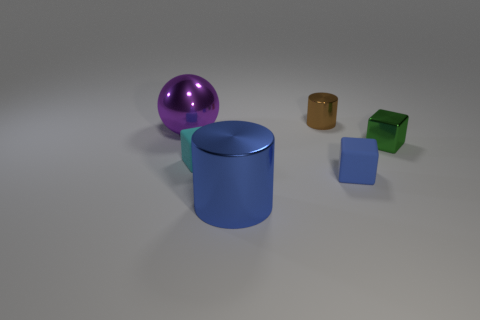What shape is the big object that is in front of the tiny rubber thing on the right side of the matte object on the left side of the small metallic cylinder?
Provide a succinct answer. Cylinder. Do the tiny thing behind the green thing and the small matte thing right of the big blue cylinder have the same color?
Provide a succinct answer. No. Is there anything else that has the same size as the blue cube?
Your answer should be very brief. Yes. Are there any matte things in front of the tiny cyan block?
Provide a succinct answer. Yes. How many other things are the same shape as the small cyan matte thing?
Your response must be concise. 2. What color is the small thing behind the tiny metallic object that is in front of the large metallic thing that is behind the small green thing?
Offer a terse response. Brown. Is the material of the cylinder behind the purple object the same as the small block left of the large blue cylinder?
Keep it short and to the point. No. How many objects are either metal things that are left of the large blue cylinder or green metallic cylinders?
Your response must be concise. 1. What number of objects are cyan metallic cubes or large things in front of the sphere?
Offer a very short reply. 1. How many blue metallic objects have the same size as the cyan object?
Provide a succinct answer. 0. 